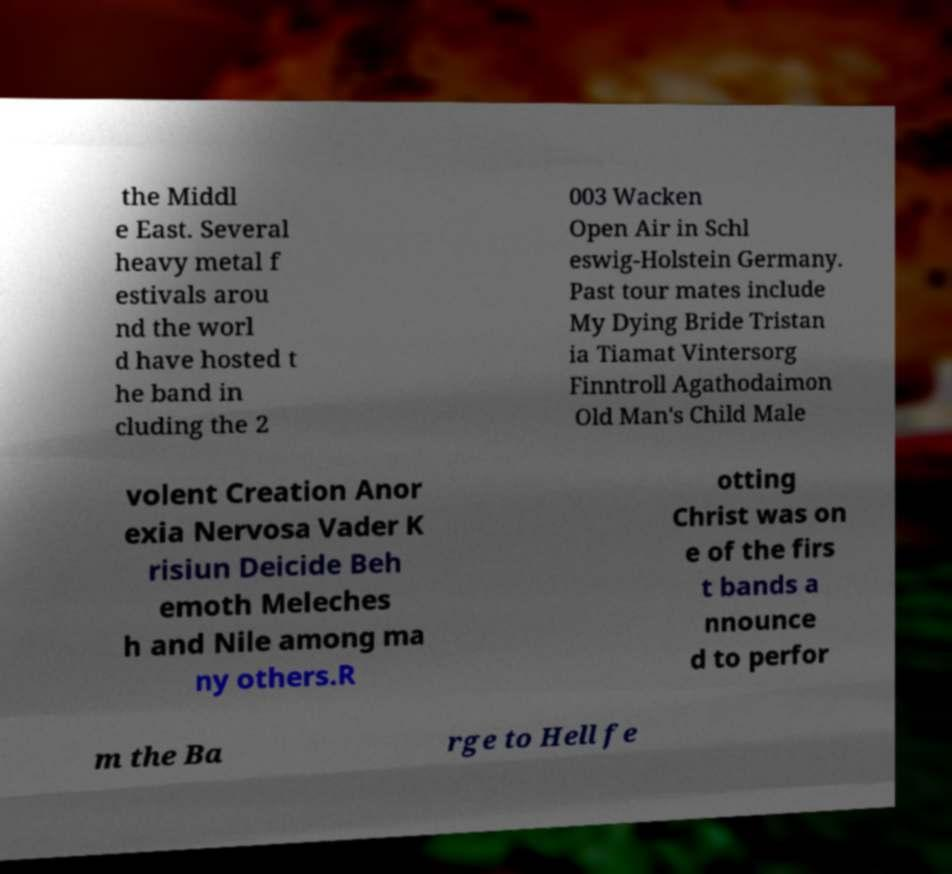I need the written content from this picture converted into text. Can you do that? the Middl e East. Several heavy metal f estivals arou nd the worl d have hosted t he band in cluding the 2 003 Wacken Open Air in Schl eswig-Holstein Germany. Past tour mates include My Dying Bride Tristan ia Tiamat Vintersorg Finntroll Agathodaimon Old Man's Child Male volent Creation Anor exia Nervosa Vader K risiun Deicide Beh emoth Meleches h and Nile among ma ny others.R otting Christ was on e of the firs t bands a nnounce d to perfor m the Ba rge to Hell fe 